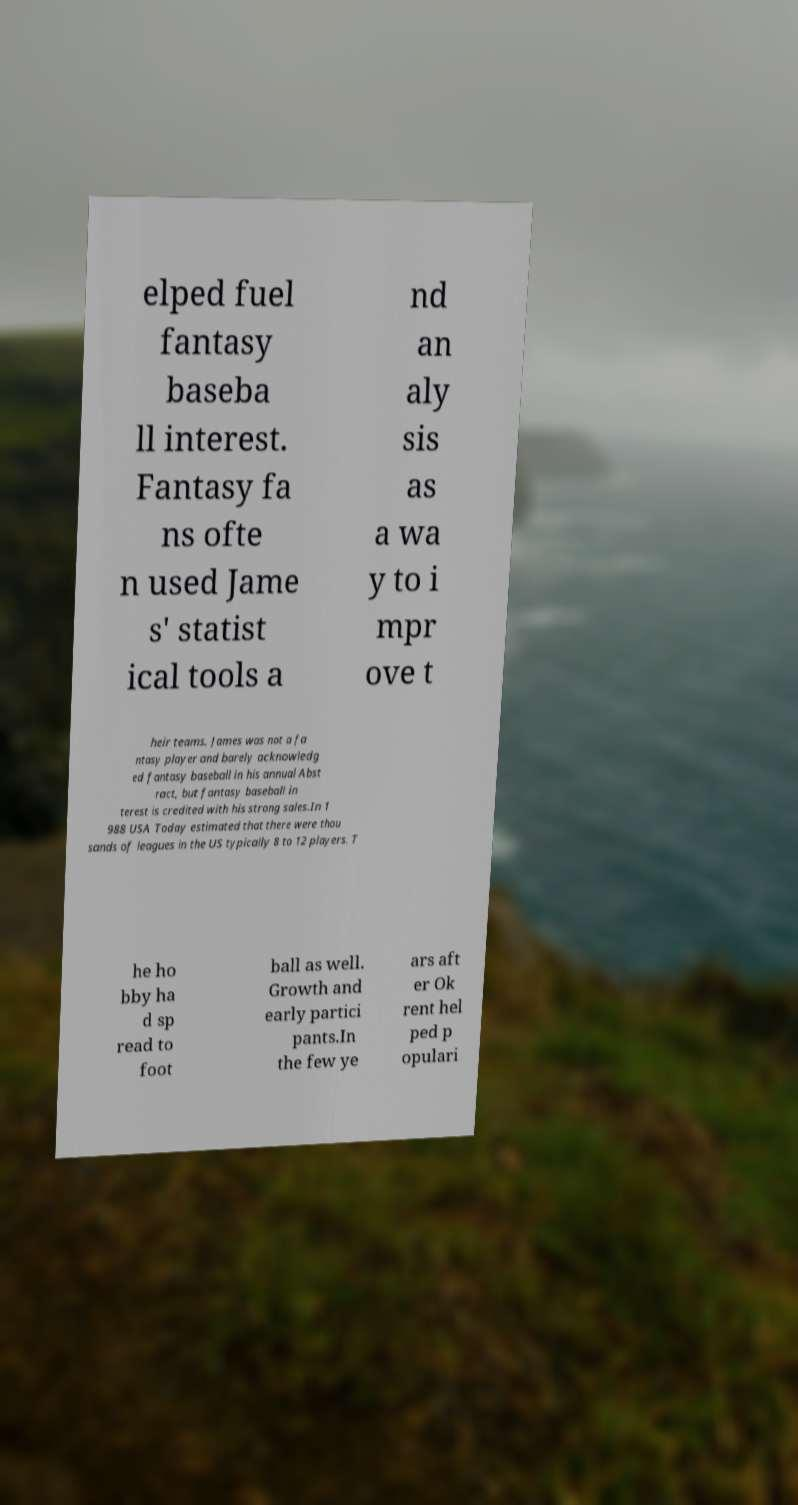Can you accurately transcribe the text from the provided image for me? elped fuel fantasy baseba ll interest. Fantasy fa ns ofte n used Jame s' statist ical tools a nd an aly sis as a wa y to i mpr ove t heir teams. James was not a fa ntasy player and barely acknowledg ed fantasy baseball in his annual Abst ract, but fantasy baseball in terest is credited with his strong sales.In 1 988 USA Today estimated that there were thou sands of leagues in the US typically 8 to 12 players. T he ho bby ha d sp read to foot ball as well. Growth and early partici pants.In the few ye ars aft er Ok rent hel ped p opulari 